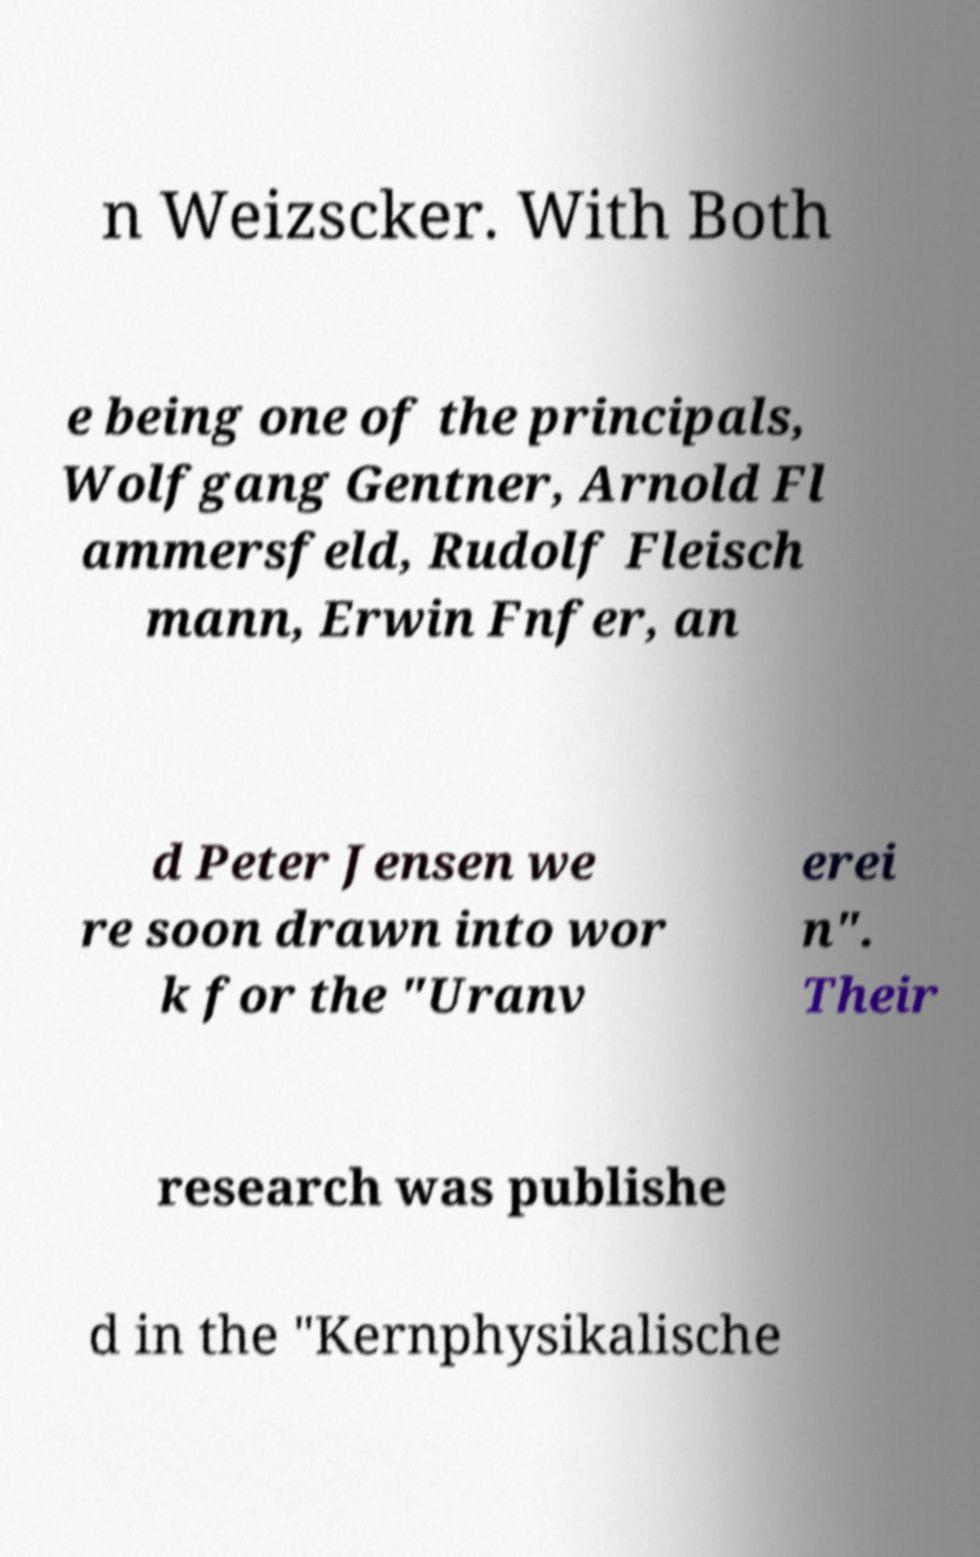Please identify and transcribe the text found in this image. n Weizscker. With Both e being one of the principals, Wolfgang Gentner, Arnold Fl ammersfeld, Rudolf Fleisch mann, Erwin Fnfer, an d Peter Jensen we re soon drawn into wor k for the "Uranv erei n". Their research was publishe d in the "Kernphysikalische 